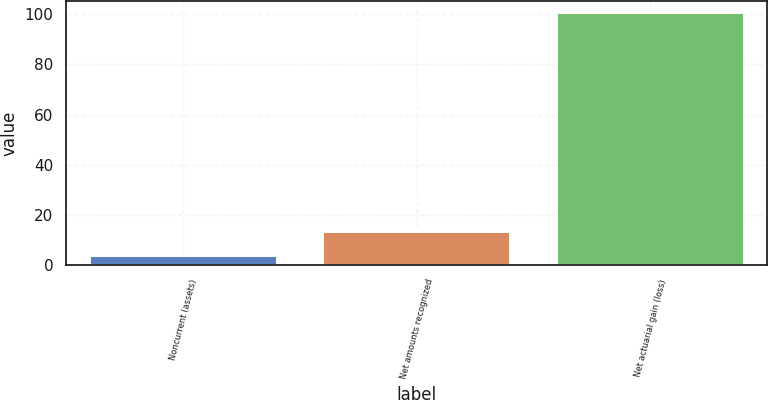Convert chart to OTSL. <chart><loc_0><loc_0><loc_500><loc_500><bar_chart><fcel>Noncurrent (assets)<fcel>Net amounts recognized<fcel>Net actuarial gain (loss)<nl><fcel>3.5<fcel>13.19<fcel>100.4<nl></chart> 